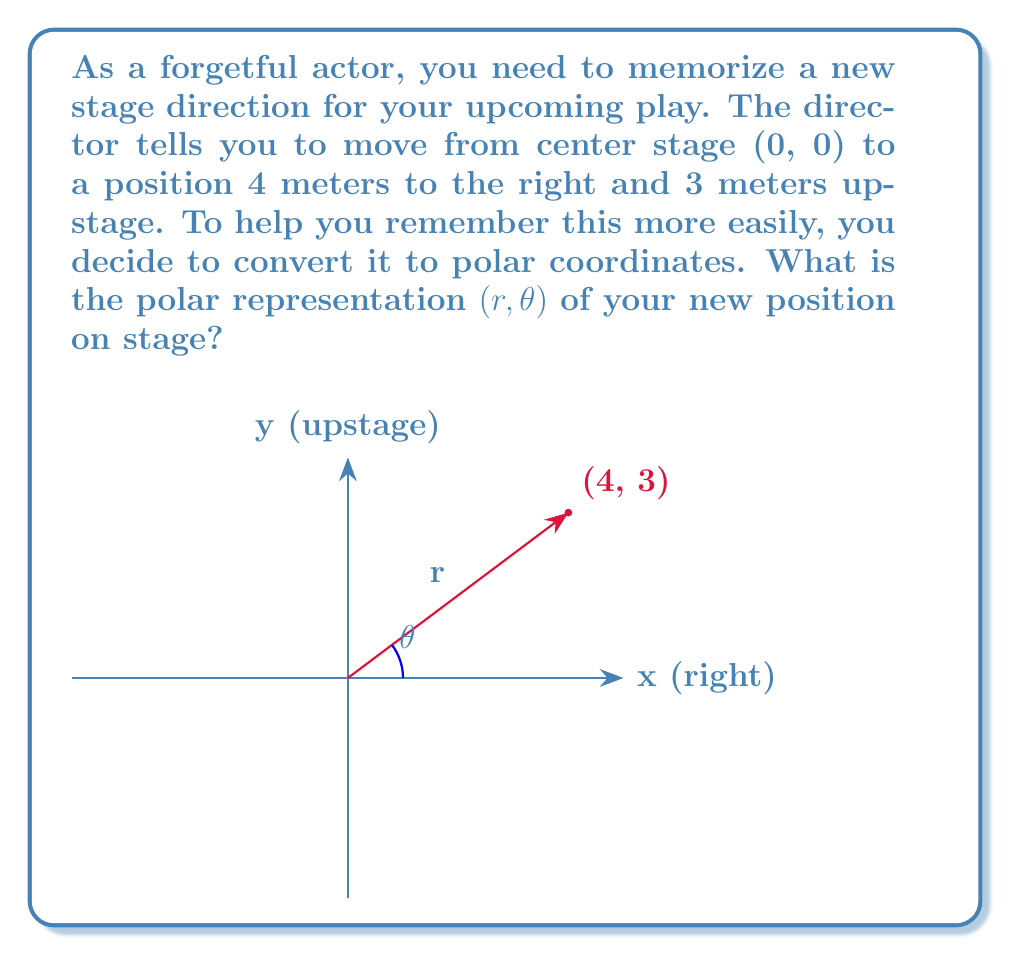What is the answer to this math problem? Let's approach this step-by-step:

1) In Cartesian coordinates, the position is (4, 3).

2) To convert from Cartesian (x, y) to polar (r, θ) coordinates, we use these formulas:

   $r = \sqrt{x^2 + y^2}$
   $\theta = \tan^{-1}(\frac{y}{x})$

3) Let's calculate r first:
   $r = \sqrt{4^2 + 3^2} = \sqrt{16 + 9} = \sqrt{25} = 5$

4) Now for θ:
   $\theta = \tan^{-1}(\frac{3}{4})$

5) Using a calculator or trigonometric tables, we find:
   $\theta \approx 0.6435$ radians

6) However, it's often more useful to express this angle in degrees:
   $0.6435 \text{ radians} \times \frac{180°}{\pi} \approx 36.87°$

7) Rounding to the nearest degree, we get 37°.

Therefore, the polar coordinates are approximately (5, 37°).
Answer: $(5, 37°)$ 